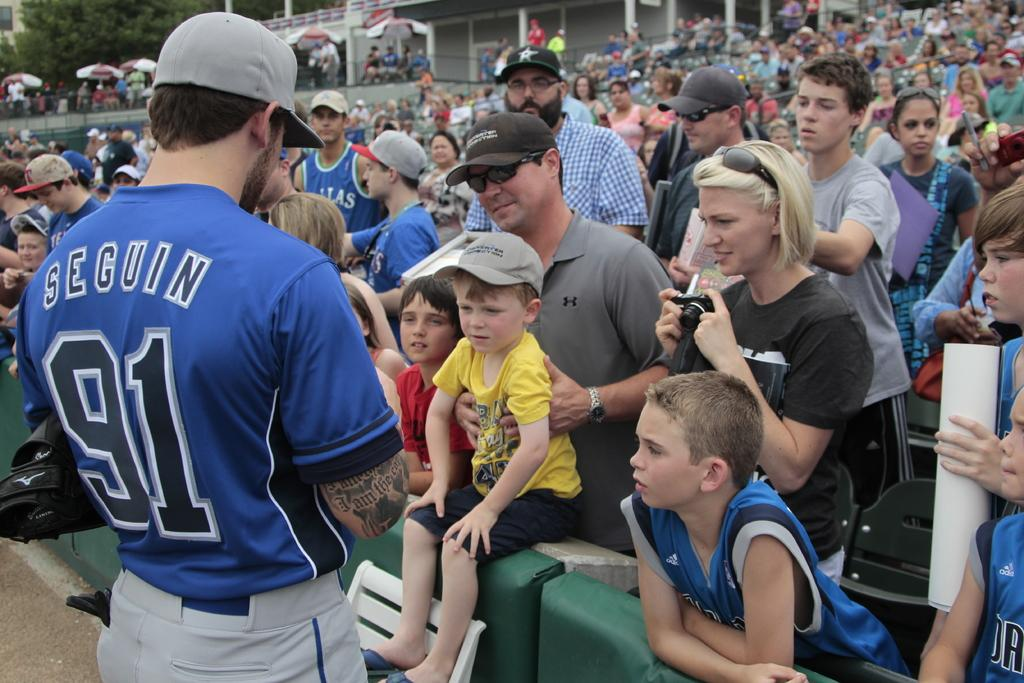<image>
Summarize the visual content of the image. A man named Seguin in a number 91 baseball jersey talks to fans in the stands. 